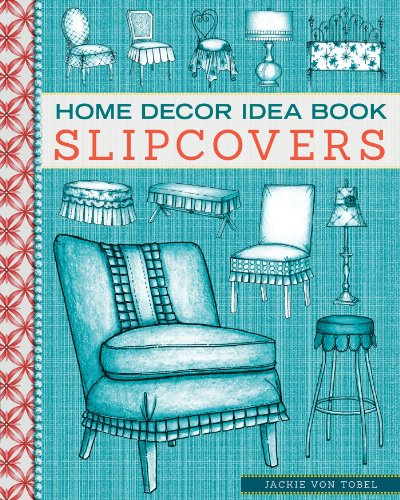Is this book related to Travel? No, this book is not related to travel. It is focused on home decoration and furniture refurbishing, which pertains to interior design rather than travel. 